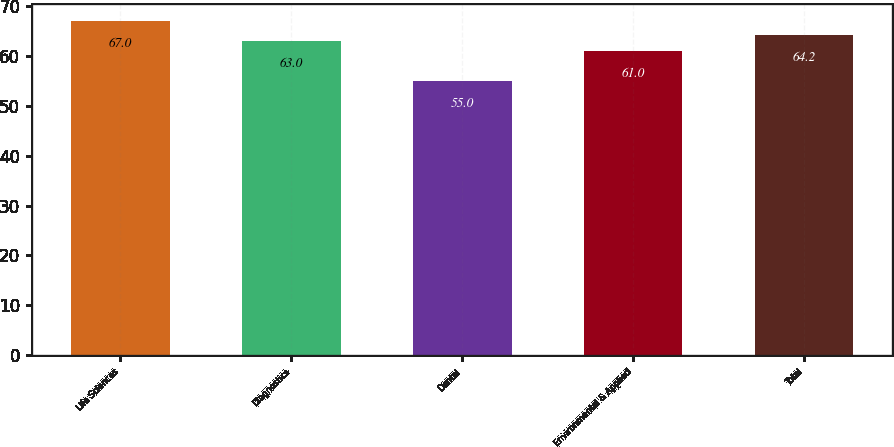<chart> <loc_0><loc_0><loc_500><loc_500><bar_chart><fcel>Life Sciences<fcel>Diagnostics<fcel>Dental<fcel>Environmental & Applied<fcel>Total<nl><fcel>67<fcel>63<fcel>55<fcel>61<fcel>64.2<nl></chart> 